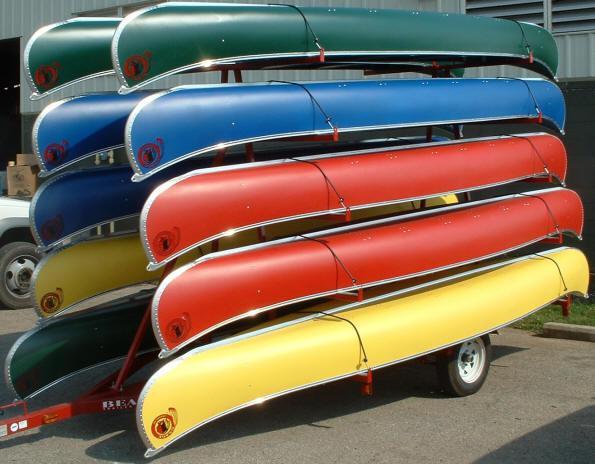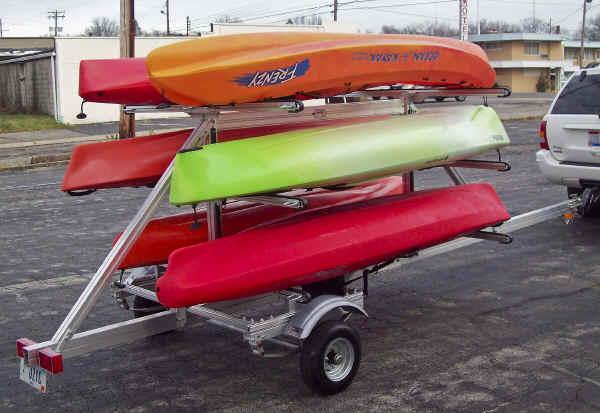The first image is the image on the left, the second image is the image on the right. Analyze the images presented: Is the assertion "At least one image shows a dark red SUV with multiple canoes on top." valid? Answer yes or no. No. The first image is the image on the left, the second image is the image on the right. Examine the images to the left and right. Is the description "Multiple boats are attached to the top of no less than one car" accurate? Answer yes or no. No. 